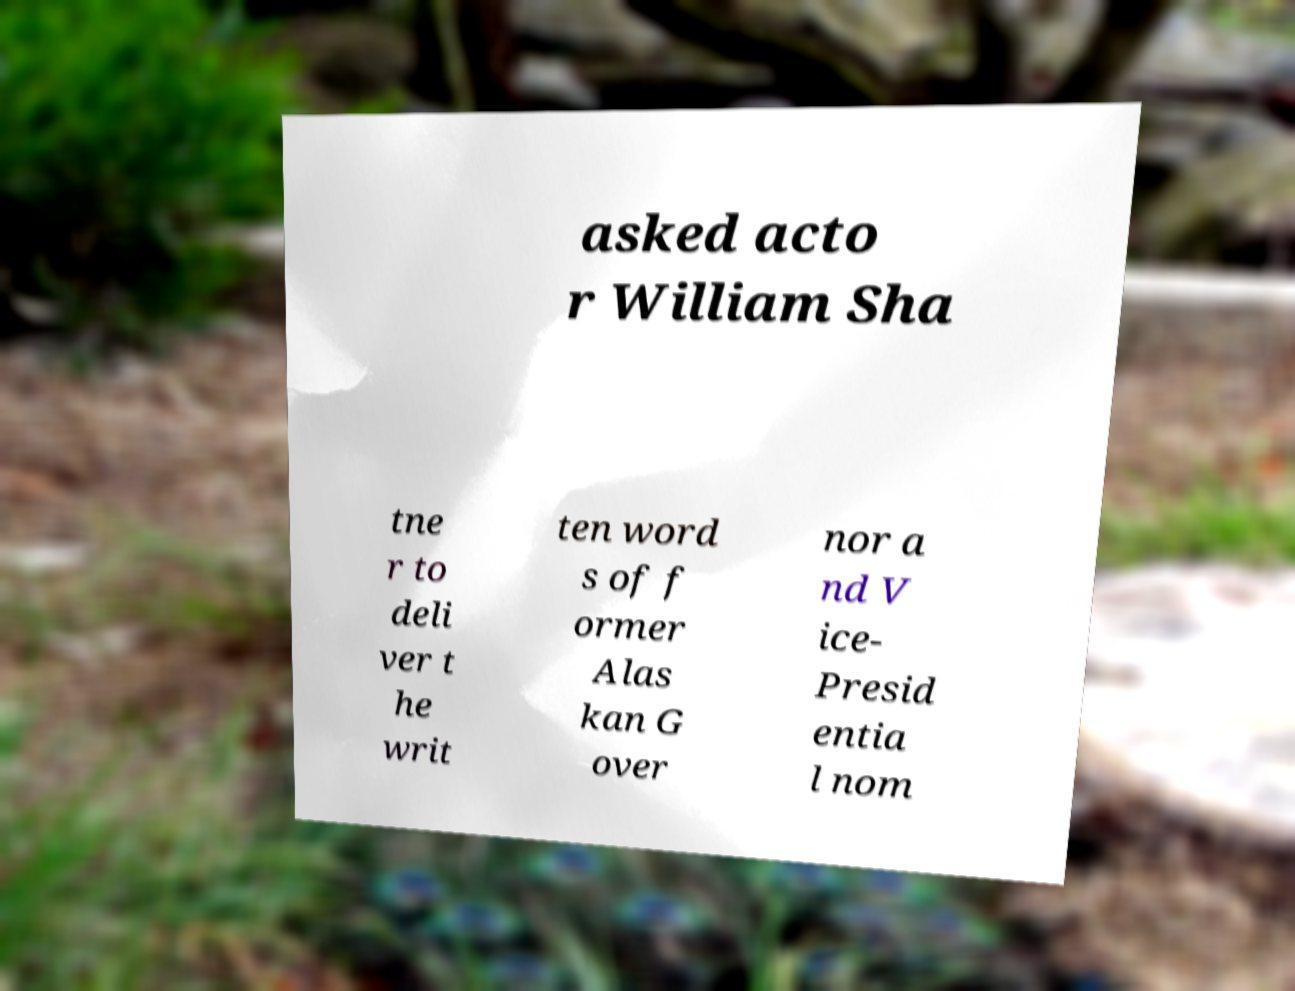Can you accurately transcribe the text from the provided image for me? asked acto r William Sha tne r to deli ver t he writ ten word s of f ormer Alas kan G over nor a nd V ice- Presid entia l nom 